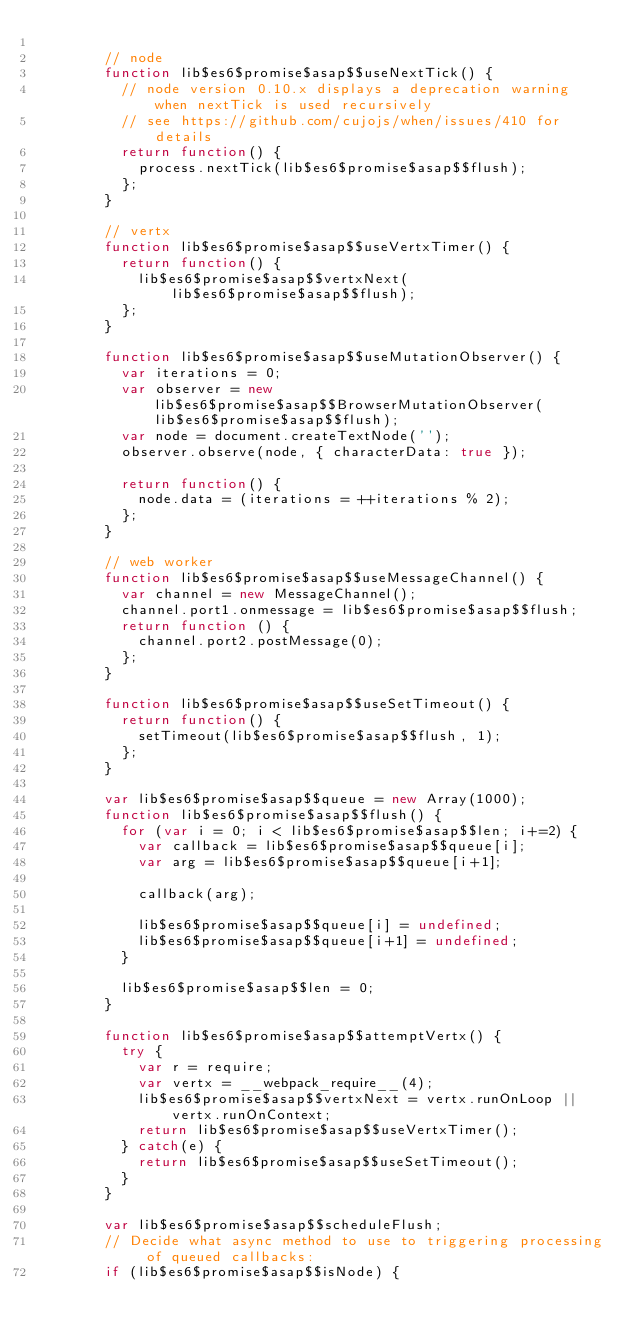<code> <loc_0><loc_0><loc_500><loc_500><_JavaScript_>	
	    // node
	    function lib$es6$promise$asap$$useNextTick() {
	      // node version 0.10.x displays a deprecation warning when nextTick is used recursively
	      // see https://github.com/cujojs/when/issues/410 for details
	      return function() {
	        process.nextTick(lib$es6$promise$asap$$flush);
	      };
	    }
	
	    // vertx
	    function lib$es6$promise$asap$$useVertxTimer() {
	      return function() {
	        lib$es6$promise$asap$$vertxNext(lib$es6$promise$asap$$flush);
	      };
	    }
	
	    function lib$es6$promise$asap$$useMutationObserver() {
	      var iterations = 0;
	      var observer = new lib$es6$promise$asap$$BrowserMutationObserver(lib$es6$promise$asap$$flush);
	      var node = document.createTextNode('');
	      observer.observe(node, { characterData: true });
	
	      return function() {
	        node.data = (iterations = ++iterations % 2);
	      };
	    }
	
	    // web worker
	    function lib$es6$promise$asap$$useMessageChannel() {
	      var channel = new MessageChannel();
	      channel.port1.onmessage = lib$es6$promise$asap$$flush;
	      return function () {
	        channel.port2.postMessage(0);
	      };
	    }
	
	    function lib$es6$promise$asap$$useSetTimeout() {
	      return function() {
	        setTimeout(lib$es6$promise$asap$$flush, 1);
	      };
	    }
	
	    var lib$es6$promise$asap$$queue = new Array(1000);
	    function lib$es6$promise$asap$$flush() {
	      for (var i = 0; i < lib$es6$promise$asap$$len; i+=2) {
	        var callback = lib$es6$promise$asap$$queue[i];
	        var arg = lib$es6$promise$asap$$queue[i+1];
	
	        callback(arg);
	
	        lib$es6$promise$asap$$queue[i] = undefined;
	        lib$es6$promise$asap$$queue[i+1] = undefined;
	      }
	
	      lib$es6$promise$asap$$len = 0;
	    }
	
	    function lib$es6$promise$asap$$attemptVertx() {
	      try {
	        var r = require;
	        var vertx = __webpack_require__(4);
	        lib$es6$promise$asap$$vertxNext = vertx.runOnLoop || vertx.runOnContext;
	        return lib$es6$promise$asap$$useVertxTimer();
	      } catch(e) {
	        return lib$es6$promise$asap$$useSetTimeout();
	      }
	    }
	
	    var lib$es6$promise$asap$$scheduleFlush;
	    // Decide what async method to use to triggering processing of queued callbacks:
	    if (lib$es6$promise$asap$$isNode) {</code> 